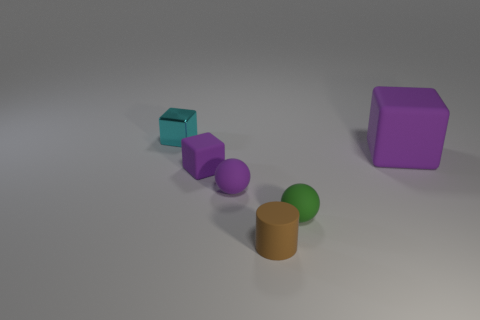What number of other things are there of the same size as the cyan metallic block?
Keep it short and to the point. 4. What number of objects are either small things that are behind the small purple rubber cube or large matte objects that are behind the tiny green matte sphere?
Provide a succinct answer. 2. The other metal thing that is the same size as the brown thing is what shape?
Your answer should be compact. Cube. There is another purple cube that is the same material as the tiny purple cube; what is its size?
Your answer should be compact. Large. Is the small cyan thing the same shape as the large purple object?
Ensure brevity in your answer.  Yes. What color is the metal thing that is the same size as the matte cylinder?
Your response must be concise. Cyan. What shape is the purple matte object that is right of the rubber cylinder?
Offer a very short reply. Cube. Do the green matte object and the small purple matte thing right of the small matte cube have the same shape?
Provide a succinct answer. Yes. Are there an equal number of green matte things right of the green thing and cyan metallic objects that are right of the brown matte thing?
Provide a short and direct response. Yes. What shape is the large rubber object that is the same color as the small rubber cube?
Offer a terse response. Cube. 